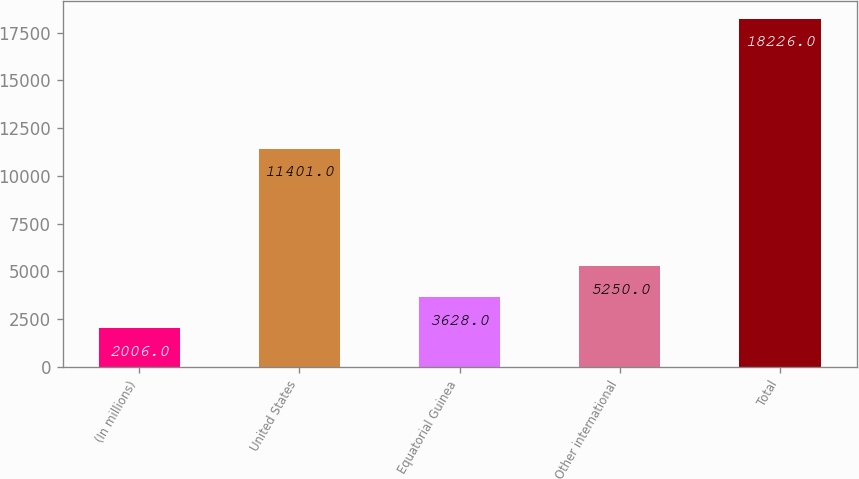Convert chart to OTSL. <chart><loc_0><loc_0><loc_500><loc_500><bar_chart><fcel>(In millions)<fcel>United States<fcel>Equatorial Guinea<fcel>Other international<fcel>Total<nl><fcel>2006<fcel>11401<fcel>3628<fcel>5250<fcel>18226<nl></chart> 